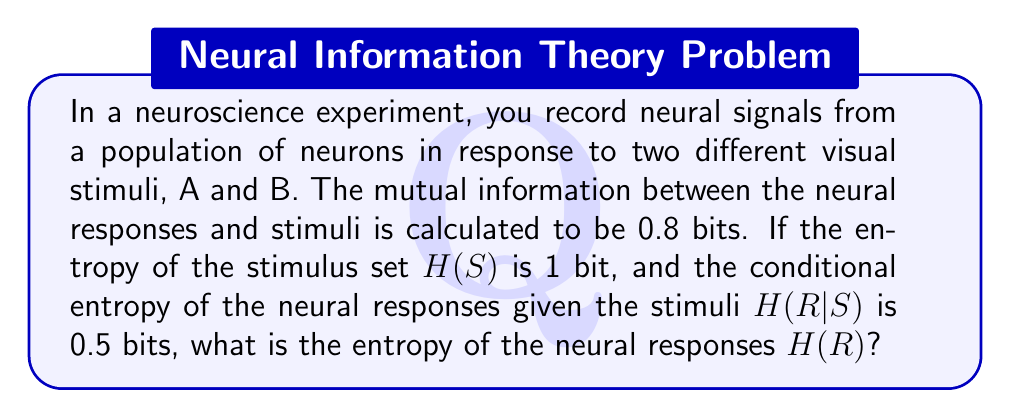Could you help me with this problem? Let's approach this step-by-step using information theory principles:

1) The mutual information I(R;S) between the neural responses (R) and stimuli (S) is given by:

   $$I(R;S) = H(R) - H(R|S)$$

   where H(R) is the entropy of the neural responses and H(R|S) is the conditional entropy of the responses given the stimuli.

2) We're given that I(R;S) = 0.8 bits and H(R|S) = 0.5 bits. Let's substitute these into the equation:

   $$0.8 = H(R) - 0.5$$

3) Solving for H(R):

   $$H(R) = 0.8 + 0.5 = 1.3 \text{ bits}$$

4) We can verify this result using an alternative formula for mutual information:

   $$I(R;S) = H(R) + H(S) - H(R,S)$$

   where H(R,S) is the joint entropy of R and S.

5) We know that H(S) = 1 bit and I(R;S) = 0.8 bits. Substituting our calculated H(R):

   $$0.8 = 1.3 + 1 - H(R,S)$$

6) Solving for H(R,S):

   $$H(R,S) = 1.3 + 1 - 0.8 = 1.5 \text{ bits}$$

7) This checks out because H(R,S) should equal H(R) + H(S|R), and we know that H(S|R) = H(S) - I(R;S) = 1 - 0.8 = 0.2 bits.

   Indeed, 1.3 + 0.2 = 1.5 bits.

Therefore, our calculation of H(R) = 1.3 bits is consistent with all given information.
Answer: 1.3 bits 